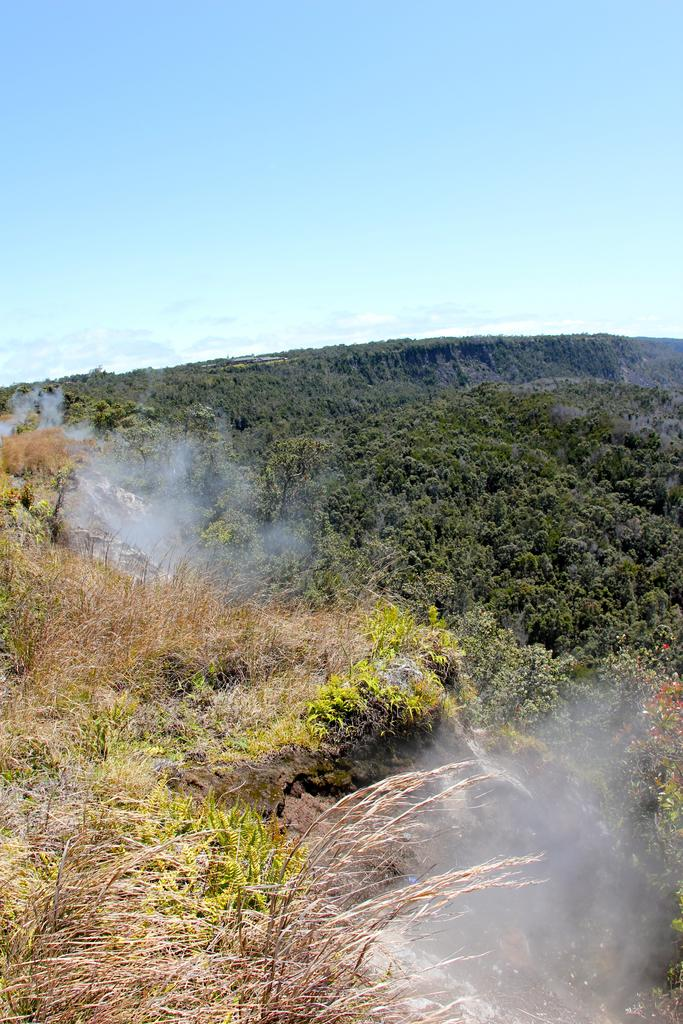Where was the picture taken? The picture was clicked outside. What can be seen in the foreground of the image? There is grass and plants in the foreground of the image. What is visible in the foreground of the image, besides the grass and plants? There is smoke visible in the foreground of the image. What can be seen in the background of the image? The sky is visible in the background of the image. How does the person in the image push the waves away? There is no person or waves present in the image; it features grass, plants, smoke, and the sky. 